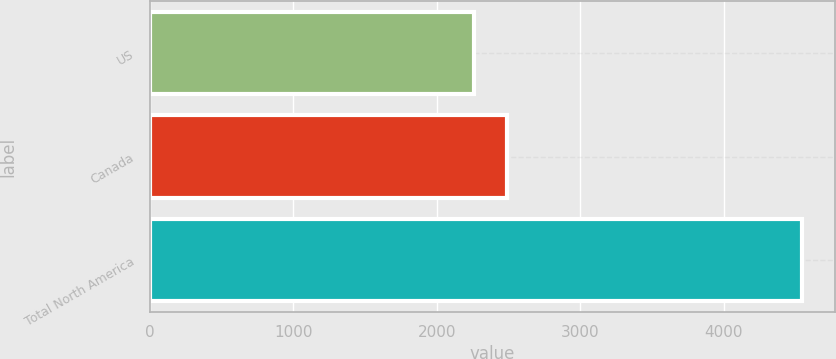Convert chart. <chart><loc_0><loc_0><loc_500><loc_500><bar_chart><fcel>US<fcel>Canada<fcel>Total North America<nl><fcel>2263<fcel>2491.6<fcel>4549<nl></chart> 